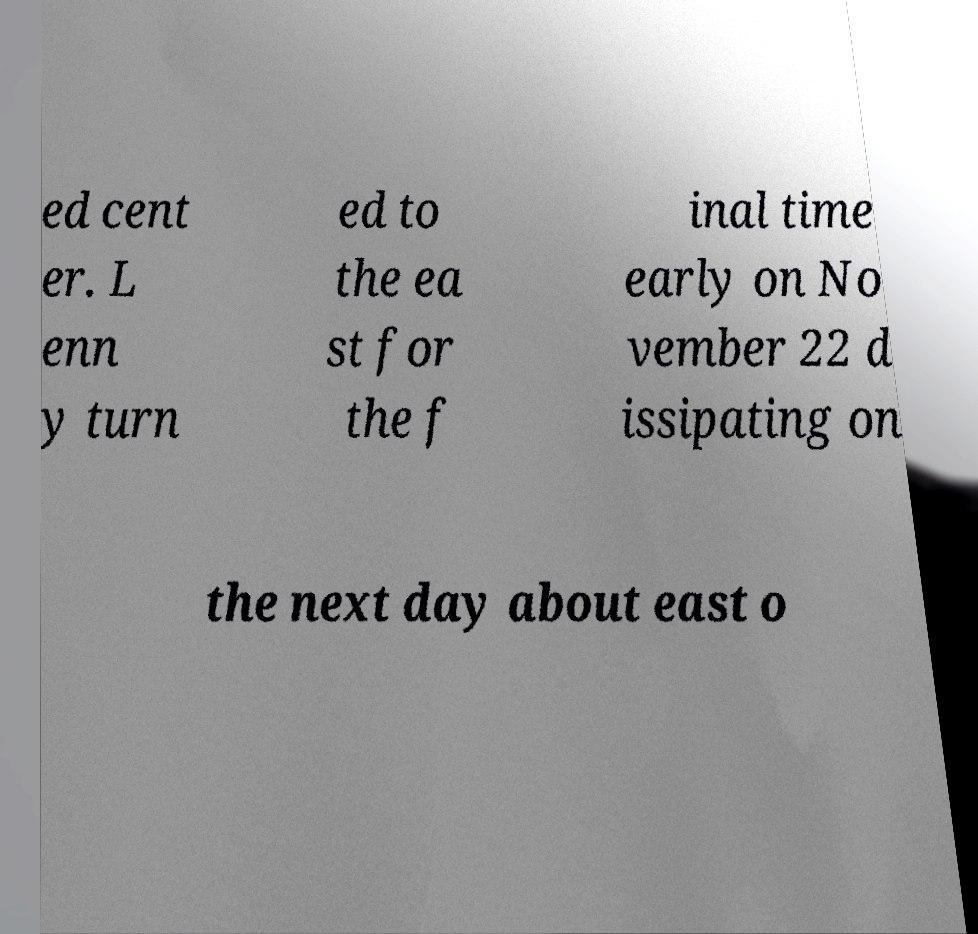Please identify and transcribe the text found in this image. ed cent er. L enn y turn ed to the ea st for the f inal time early on No vember 22 d issipating on the next day about east o 